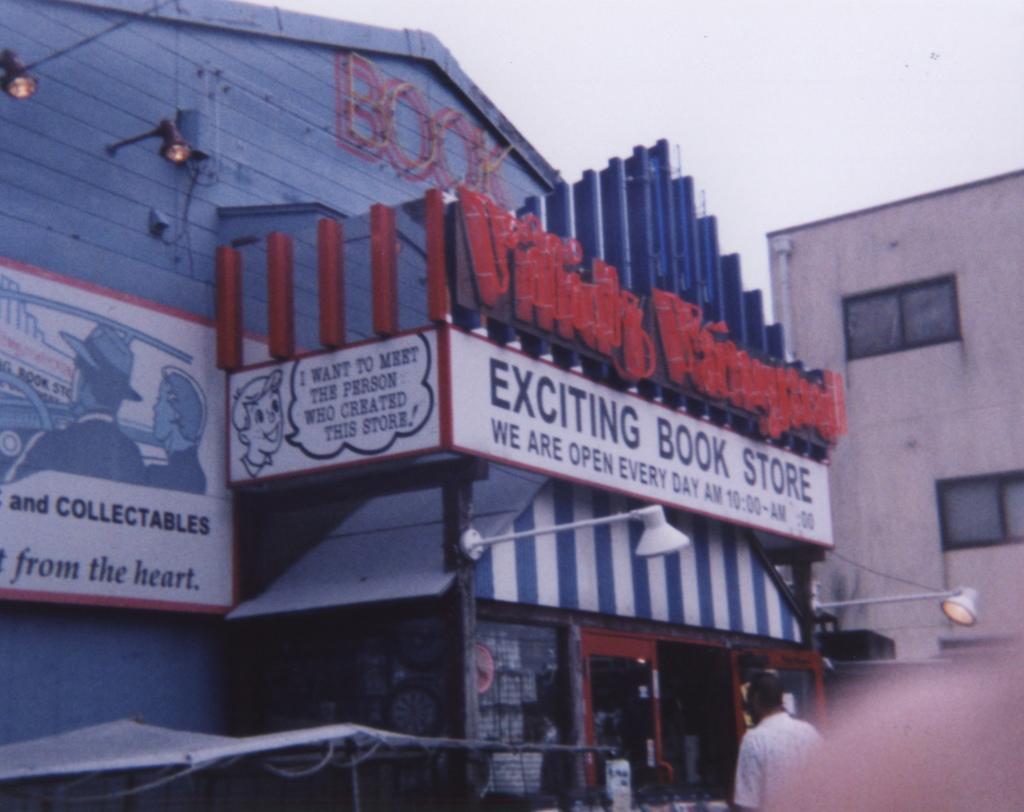Could you give a brief overview of what you see in this image? In this picture we can see buildings, there are boards in the middle, we can see some text on these boards, on the right side there are two lights, we can see a person at the bottom, there is the sky at the top of the picture. 